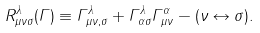<formula> <loc_0><loc_0><loc_500><loc_500>R ^ { \lambda } _ { \mu \nu \sigma } ( \Gamma ) \equiv \Gamma ^ { \lambda } _ { \mu \nu , \sigma } + \Gamma ^ { \lambda } _ { \alpha \sigma } \Gamma ^ { \alpha } _ { \mu \nu } - ( \nu \leftrightarrow \sigma ) .</formula> 